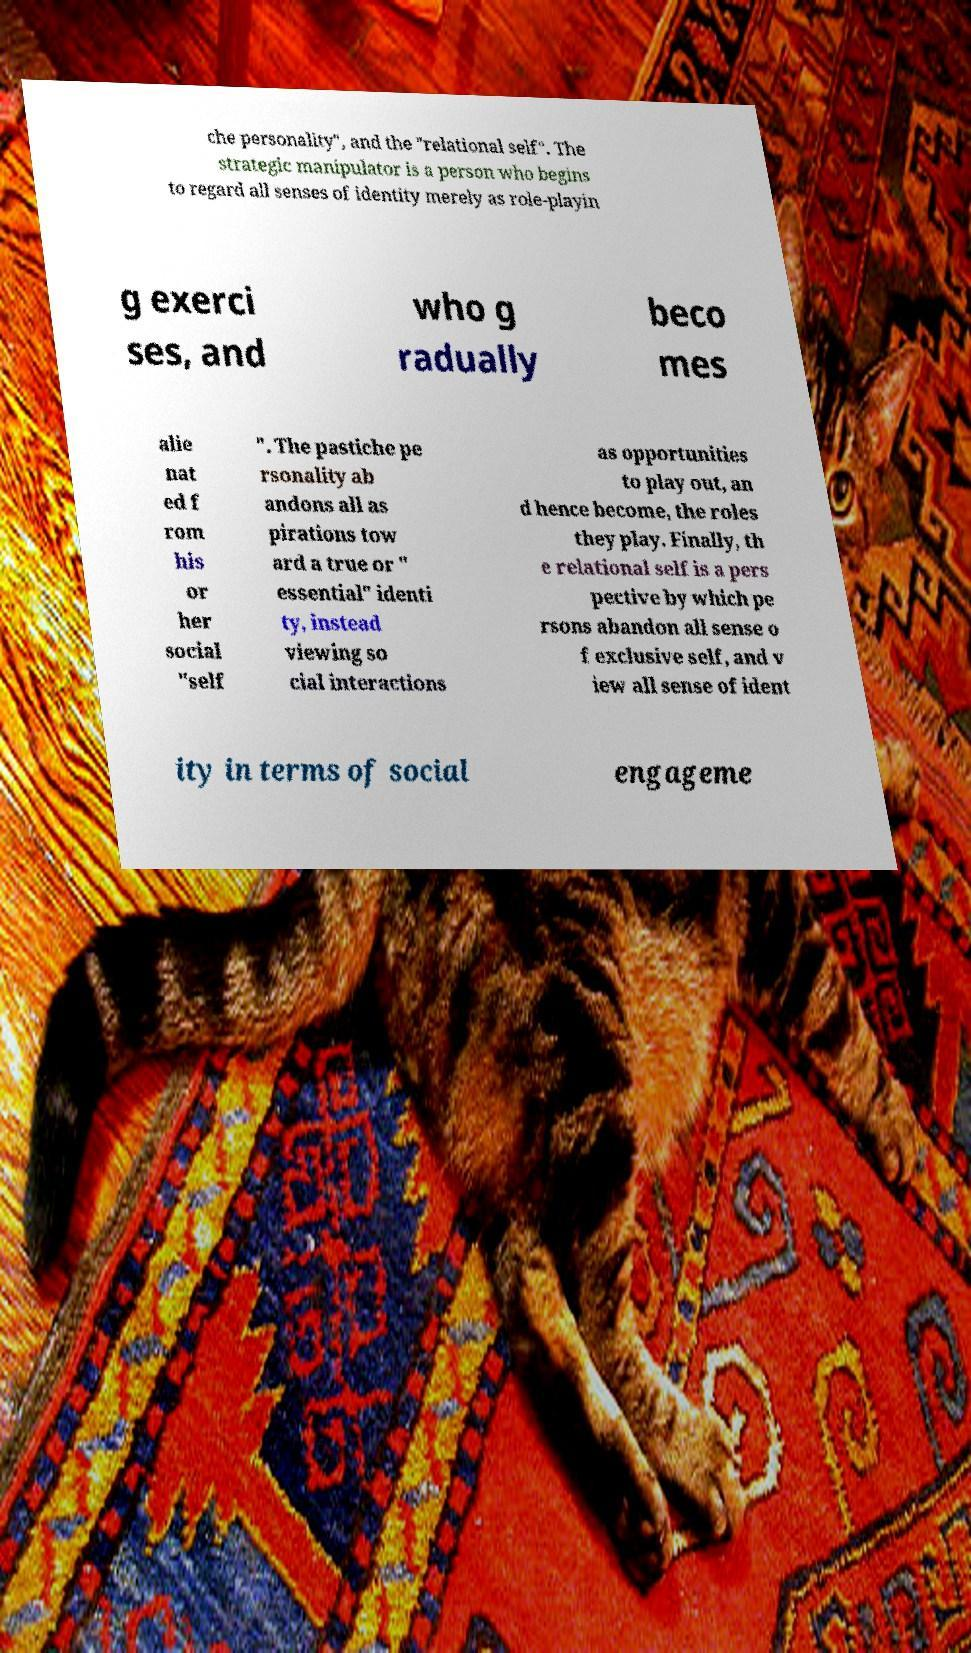Can you accurately transcribe the text from the provided image for me? che personality", and the "relational self". The strategic manipulator is a person who begins to regard all senses of identity merely as role-playin g exerci ses, and who g radually beco mes alie nat ed f rom his or her social "self ". The pastiche pe rsonality ab andons all as pirations tow ard a true or " essential" identi ty, instead viewing so cial interactions as opportunities to play out, an d hence become, the roles they play. Finally, th e relational self is a pers pective by which pe rsons abandon all sense o f exclusive self, and v iew all sense of ident ity in terms of social engageme 